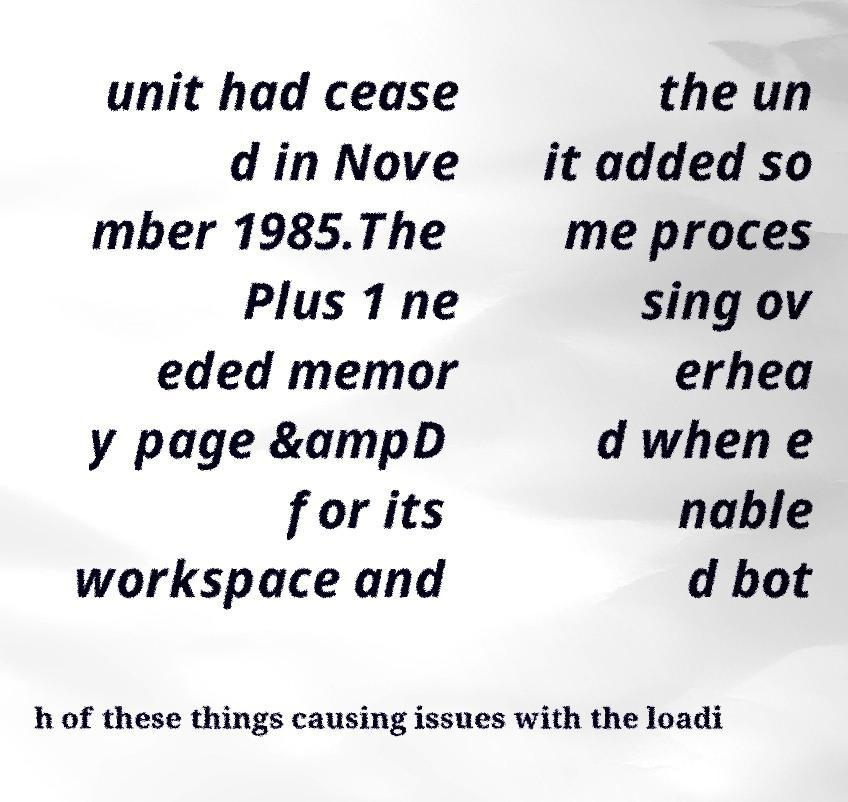Please identify and transcribe the text found in this image. unit had cease d in Nove mber 1985.The Plus 1 ne eded memor y page &ampD for its workspace and the un it added so me proces sing ov erhea d when e nable d bot h of these things causing issues with the loadi 